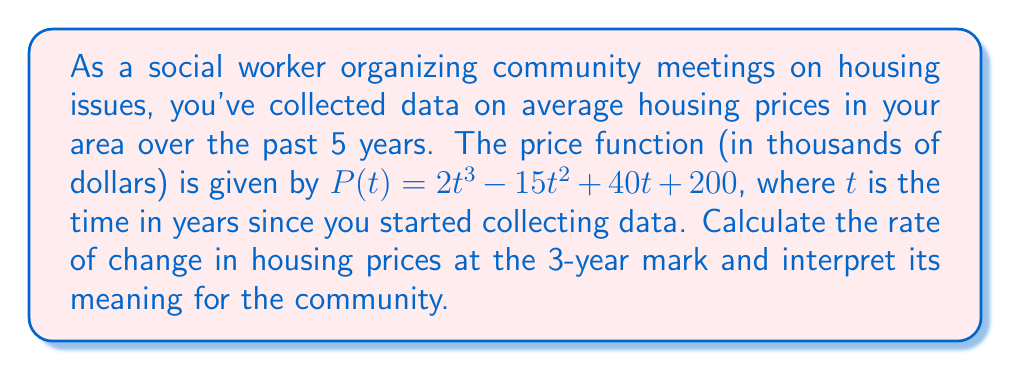Give your solution to this math problem. To solve this problem, we need to follow these steps:

1) The rate of change in housing prices is given by the derivative of the price function $P(t)$.

2) First, let's find the derivative $P'(t)$:
   $$P'(t) = \frac{d}{dt}(2t^3 - 15t^2 + 40t + 200)$$
   $$P'(t) = 6t^2 - 30t + 40$$

3) We want to find the rate of change at $t = 3$ years, so we need to evaluate $P'(3)$:
   $$P'(3) = 6(3)^2 - 30(3) + 40$$
   $$P'(3) = 6(9) - 90 + 40$$
   $$P'(3) = 54 - 90 + 40 = 4$$

4) Interpretation: The rate of change at $t = 3$ is 4 thousand dollars per year. This means that after 3 years, housing prices were increasing at a rate of $4,000 per year.

For the community, this indicates that housing prices were still rising after 3 years, but at a relatively slow pace. This information could be valuable for residents planning to buy or sell homes, or for policymakers considering interventions to address housing affordability.
Answer: The rate of change in housing prices at the 3-year mark is $4,000 per year. 